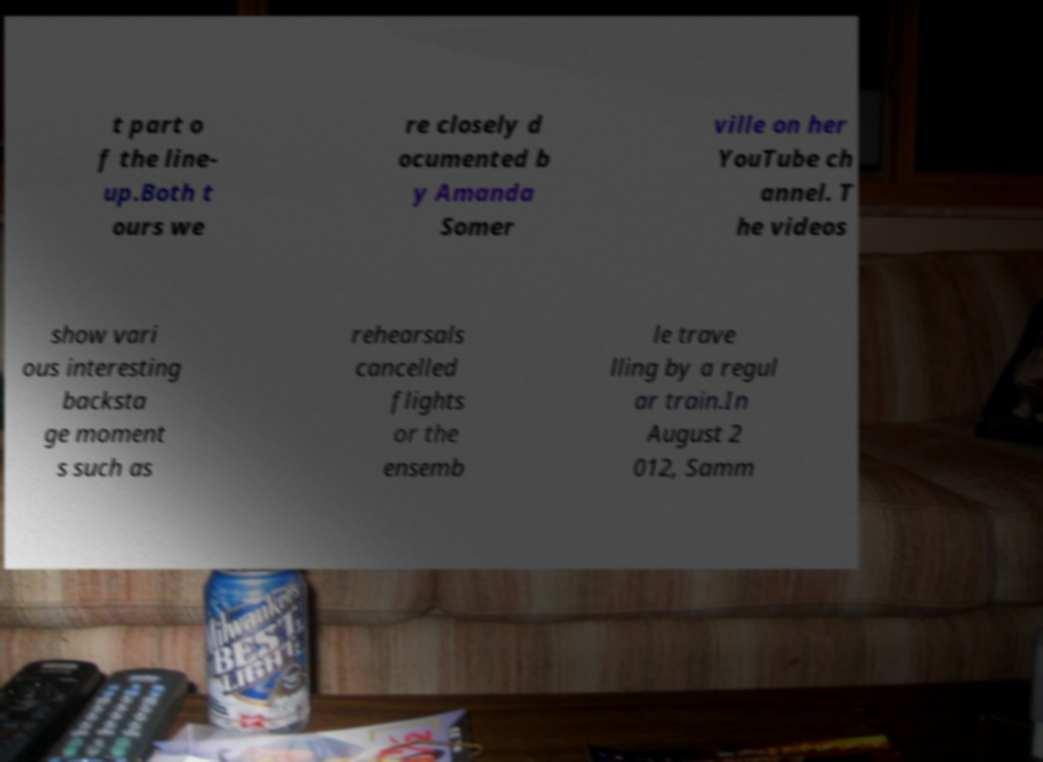What messages or text are displayed in this image? I need them in a readable, typed format. t part o f the line- up.Both t ours we re closely d ocumented b y Amanda Somer ville on her YouTube ch annel. T he videos show vari ous interesting backsta ge moment s such as rehearsals cancelled flights or the ensemb le trave lling by a regul ar train.In August 2 012, Samm 